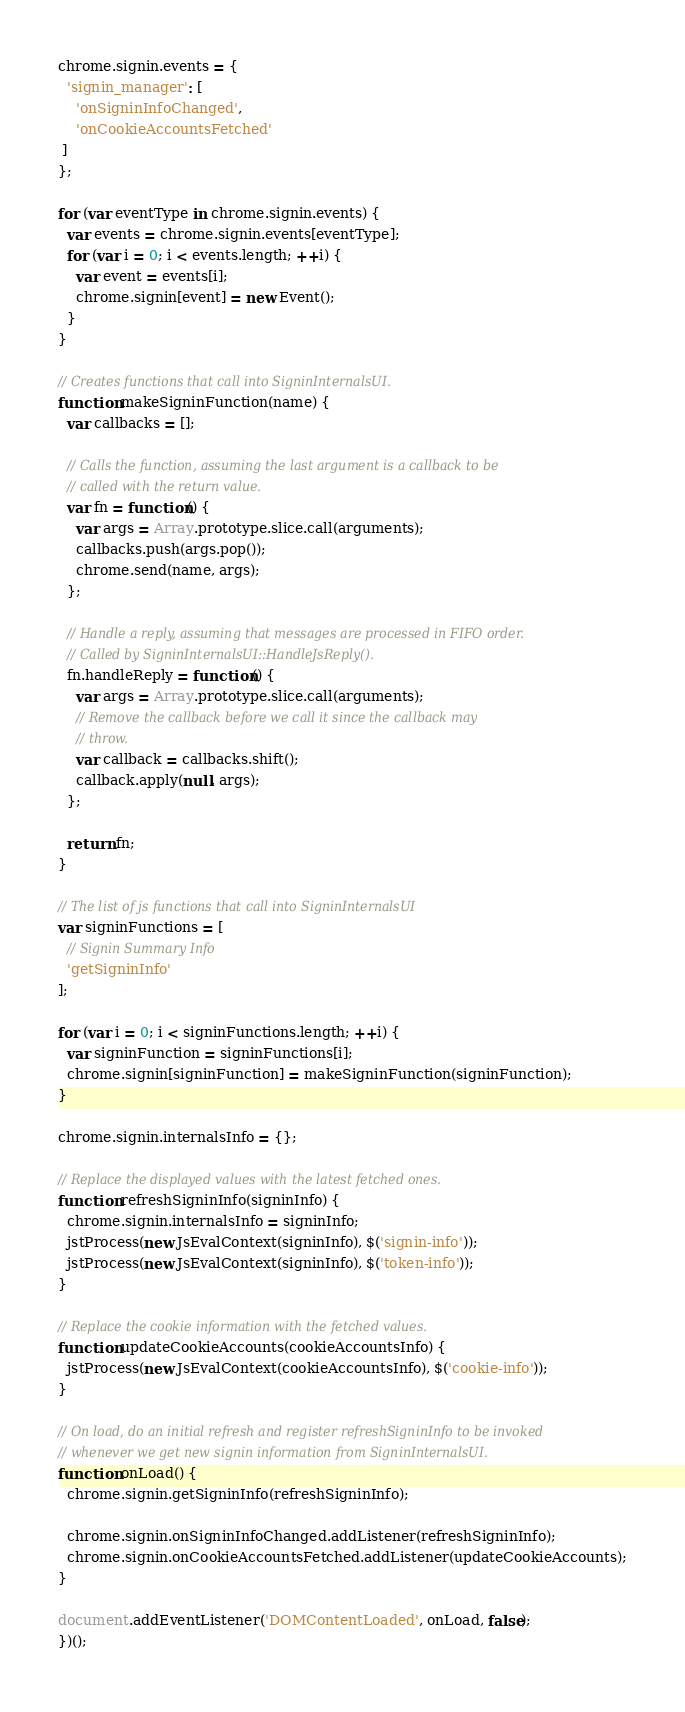Convert code to text. <code><loc_0><loc_0><loc_500><loc_500><_JavaScript_>chrome.signin.events = {
  'signin_manager': [
    'onSigninInfoChanged',
    'onCookieAccountsFetched'
 ]
};

for (var eventType in chrome.signin.events) {
  var events = chrome.signin.events[eventType];
  for (var i = 0; i < events.length; ++i) {
    var event = events[i];
    chrome.signin[event] = new Event();
  }
}

// Creates functions that call into SigninInternalsUI.
function makeSigninFunction(name) {
  var callbacks = [];

  // Calls the function, assuming the last argument is a callback to be
  // called with the return value.
  var fn = function() {
    var args = Array.prototype.slice.call(arguments);
    callbacks.push(args.pop());
    chrome.send(name, args);
  };

  // Handle a reply, assuming that messages are processed in FIFO order.
  // Called by SigninInternalsUI::HandleJsReply().
  fn.handleReply = function() {
    var args = Array.prototype.slice.call(arguments);
    // Remove the callback before we call it since the callback may
    // throw.
    var callback = callbacks.shift();
    callback.apply(null, args);
  };

  return fn;
}

// The list of js functions that call into SigninInternalsUI
var signinFunctions = [
  // Signin Summary Info
  'getSigninInfo'
];

for (var i = 0; i < signinFunctions.length; ++i) {
  var signinFunction = signinFunctions[i];
  chrome.signin[signinFunction] = makeSigninFunction(signinFunction);
}

chrome.signin.internalsInfo = {};

// Replace the displayed values with the latest fetched ones.
function refreshSigninInfo(signinInfo) {
  chrome.signin.internalsInfo = signinInfo;
  jstProcess(new JsEvalContext(signinInfo), $('signin-info'));
  jstProcess(new JsEvalContext(signinInfo), $('token-info'));
}

// Replace the cookie information with the fetched values.
function updateCookieAccounts(cookieAccountsInfo) {
  jstProcess(new JsEvalContext(cookieAccountsInfo), $('cookie-info'));
}

// On load, do an initial refresh and register refreshSigninInfo to be invoked
// whenever we get new signin information from SigninInternalsUI.
function onLoad() {
  chrome.signin.getSigninInfo(refreshSigninInfo);

  chrome.signin.onSigninInfoChanged.addListener(refreshSigninInfo);
  chrome.signin.onCookieAccountsFetched.addListener(updateCookieAccounts);
}

document.addEventListener('DOMContentLoaded', onLoad, false);
})();
</code> 